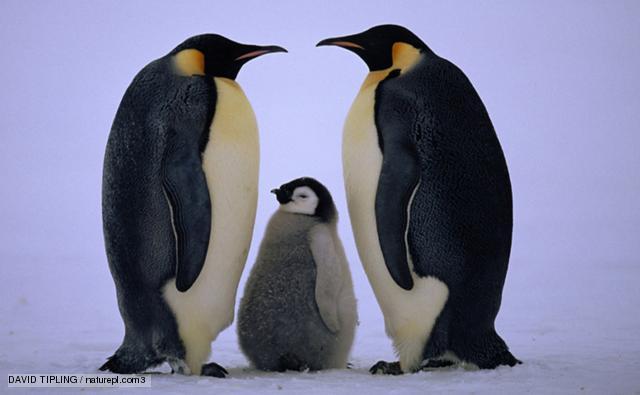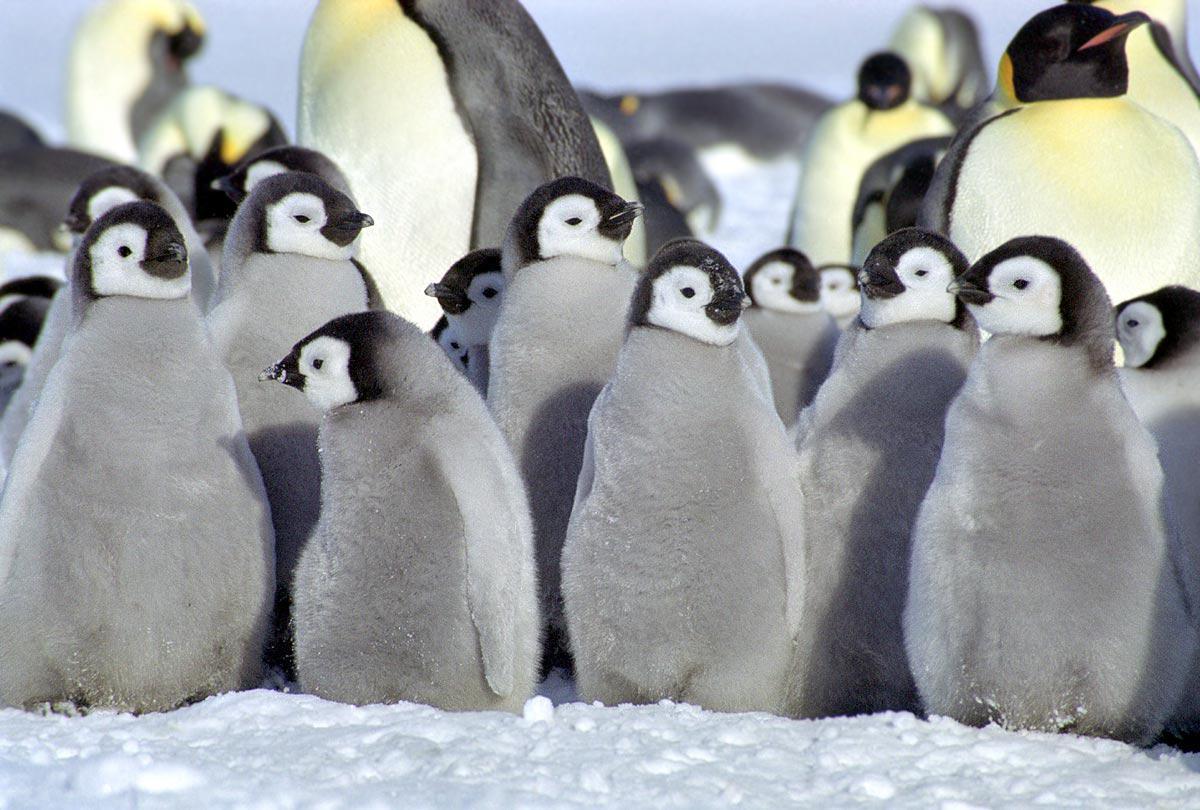The first image is the image on the left, the second image is the image on the right. Examine the images to the left and right. Is the description "One image shows only one penguin family, with parents flanking a baby." accurate? Answer yes or no. Yes. The first image is the image on the left, the second image is the image on the right. Assess this claim about the two images: "In the left image, there are two adult penguins and one baby penguin". Correct or not? Answer yes or no. Yes. 